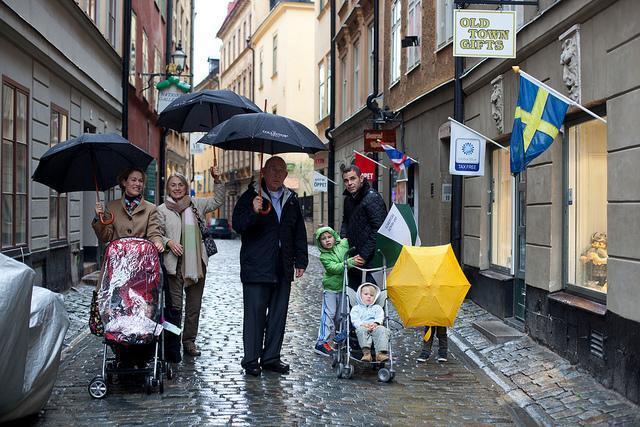How many flags are there?
Give a very brief answer. 5. How many strollers are there?
Give a very brief answer. 2. How many people are in the picture?
Give a very brief answer. 6. How many umbrellas are in the picture?
Give a very brief answer. 4. How many brown horses are jumping in this photo?
Give a very brief answer. 0. 